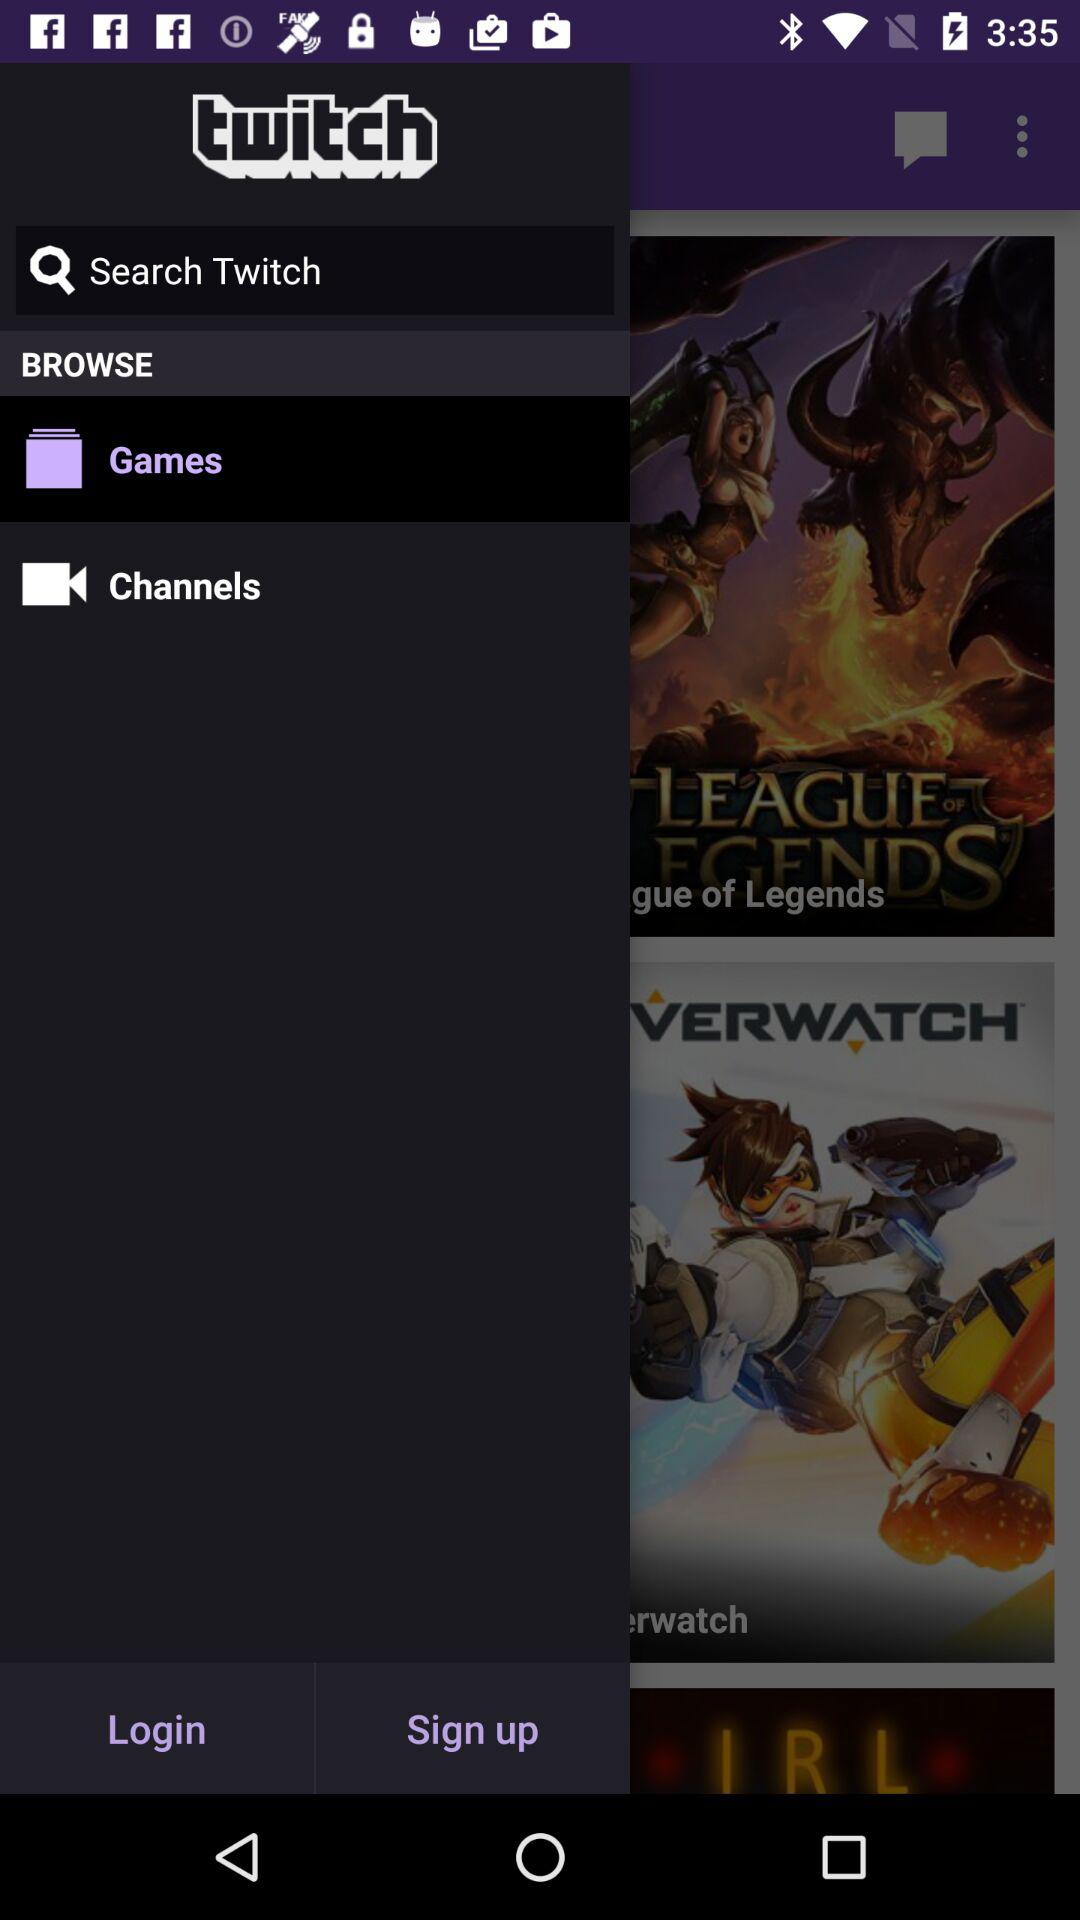Which option is selected? The selected option is "Games". 